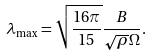<formula> <loc_0><loc_0><loc_500><loc_500>\lambda _ { \max } = \sqrt { \frac { 1 6 \pi } { 1 5 } } \frac { B } { \sqrt { \rho } \Omega } .</formula> 